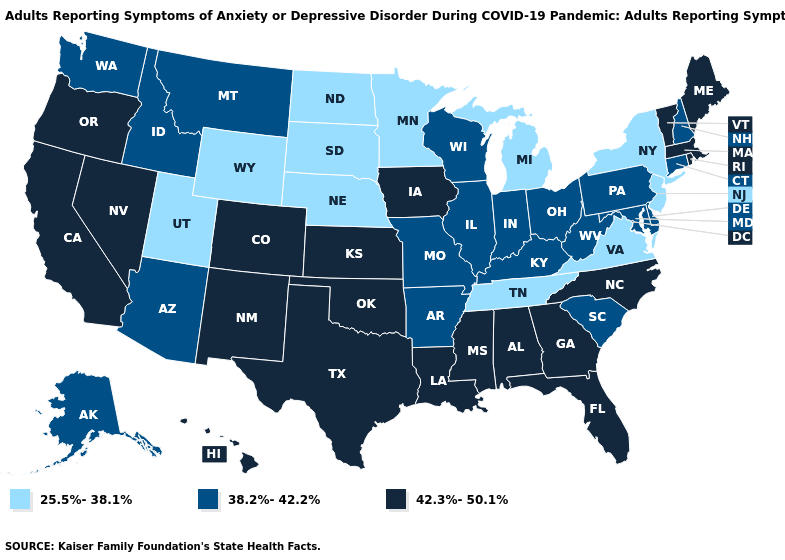Does North Carolina have the lowest value in the South?
Keep it brief. No. What is the value of Colorado?
Write a very short answer. 42.3%-50.1%. What is the value of Maryland?
Keep it brief. 38.2%-42.2%. Name the states that have a value in the range 38.2%-42.2%?
Answer briefly. Alaska, Arizona, Arkansas, Connecticut, Delaware, Idaho, Illinois, Indiana, Kentucky, Maryland, Missouri, Montana, New Hampshire, Ohio, Pennsylvania, South Carolina, Washington, West Virginia, Wisconsin. Does the first symbol in the legend represent the smallest category?
Give a very brief answer. Yes. What is the value of Alabama?
Be succinct. 42.3%-50.1%. Name the states that have a value in the range 38.2%-42.2%?
Short answer required. Alaska, Arizona, Arkansas, Connecticut, Delaware, Idaho, Illinois, Indiana, Kentucky, Maryland, Missouri, Montana, New Hampshire, Ohio, Pennsylvania, South Carolina, Washington, West Virginia, Wisconsin. Name the states that have a value in the range 25.5%-38.1%?
Give a very brief answer. Michigan, Minnesota, Nebraska, New Jersey, New York, North Dakota, South Dakota, Tennessee, Utah, Virginia, Wyoming. Does Rhode Island have the highest value in the Northeast?
Write a very short answer. Yes. What is the lowest value in the USA?
Be succinct. 25.5%-38.1%. What is the value of Arizona?
Give a very brief answer. 38.2%-42.2%. Does Hawaii have the highest value in the West?
Write a very short answer. Yes. Name the states that have a value in the range 25.5%-38.1%?
Keep it brief. Michigan, Minnesota, Nebraska, New Jersey, New York, North Dakota, South Dakota, Tennessee, Utah, Virginia, Wyoming. 